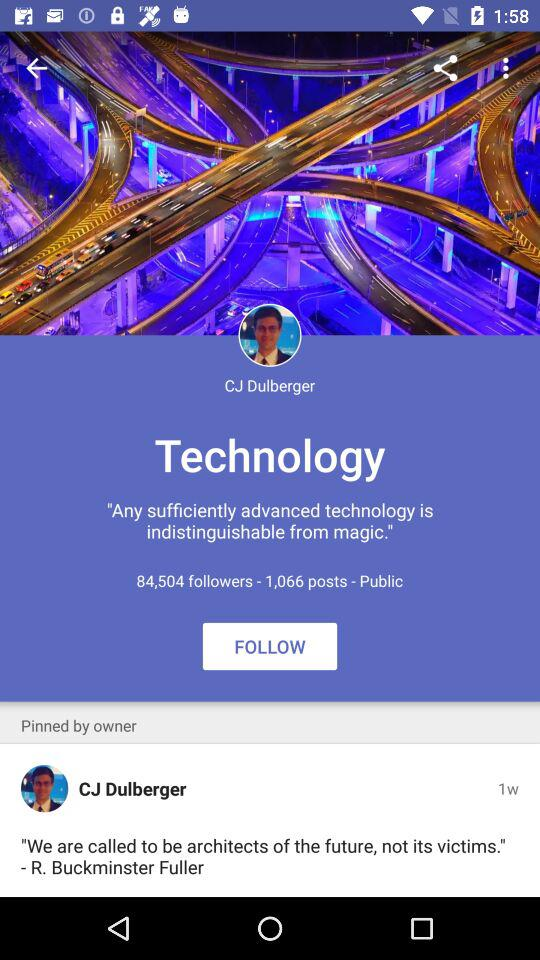How many posts are there on the profile? There are 1,066 posts. 